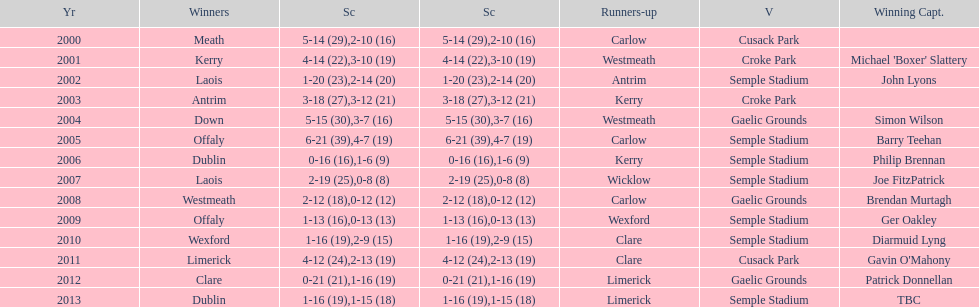Who was the winner after 2007? Laois. Help me parse the entirety of this table. {'header': ['Yr', 'Winners', 'Sc', 'Sc', 'Runners-up', 'V', 'Winning Capt.'], 'rows': [['2000', 'Meath', '5-14 (29)', '2-10 (16)', 'Carlow', 'Cusack Park', ''], ['2001', 'Kerry', '4-14 (22)', '3-10 (19)', 'Westmeath', 'Croke Park', "Michael 'Boxer' Slattery"], ['2002', 'Laois', '1-20 (23)', '2-14 (20)', 'Antrim', 'Semple Stadium', 'John Lyons'], ['2003', 'Antrim', '3-18 (27)', '3-12 (21)', 'Kerry', 'Croke Park', ''], ['2004', 'Down', '5-15 (30)', '3-7 (16)', 'Westmeath', 'Gaelic Grounds', 'Simon Wilson'], ['2005', 'Offaly', '6-21 (39)', '4-7 (19)', 'Carlow', 'Semple Stadium', 'Barry Teehan'], ['2006', 'Dublin', '0-16 (16)', '1-6 (9)', 'Kerry', 'Semple Stadium', 'Philip Brennan'], ['2007', 'Laois', '2-19 (25)', '0-8 (8)', 'Wicklow', 'Semple Stadium', 'Joe FitzPatrick'], ['2008', 'Westmeath', '2-12 (18)', '0-12 (12)', 'Carlow', 'Gaelic Grounds', 'Brendan Murtagh'], ['2009', 'Offaly', '1-13 (16)', '0-13 (13)', 'Wexford', 'Semple Stadium', 'Ger Oakley'], ['2010', 'Wexford', '1-16 (19)', '2-9 (15)', 'Clare', 'Semple Stadium', 'Diarmuid Lyng'], ['2011', 'Limerick', '4-12 (24)', '2-13 (19)', 'Clare', 'Cusack Park', "Gavin O'Mahony"], ['2012', 'Clare', '0-21 (21)', '1-16 (19)', 'Limerick', 'Gaelic Grounds', 'Patrick Donnellan'], ['2013', 'Dublin', '1-16 (19)', '1-15 (18)', 'Limerick', 'Semple Stadium', 'TBC']]} 